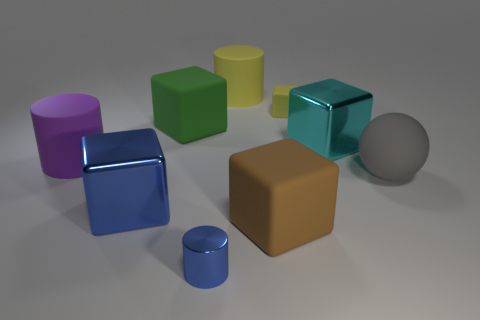Subtract 1 cylinders. How many cylinders are left? 2 Subtract all brown cubes. How many cubes are left? 4 Subtract all blue metal blocks. How many blocks are left? 4 Subtract all cyan blocks. Subtract all green balls. How many blocks are left? 4 Add 1 yellow blocks. How many objects exist? 10 Subtract all cylinders. How many objects are left? 6 Subtract 0 gray cubes. How many objects are left? 9 Subtract all gray rubber things. Subtract all cyan rubber balls. How many objects are left? 8 Add 1 matte things. How many matte things are left? 7 Add 1 shiny blocks. How many shiny blocks exist? 3 